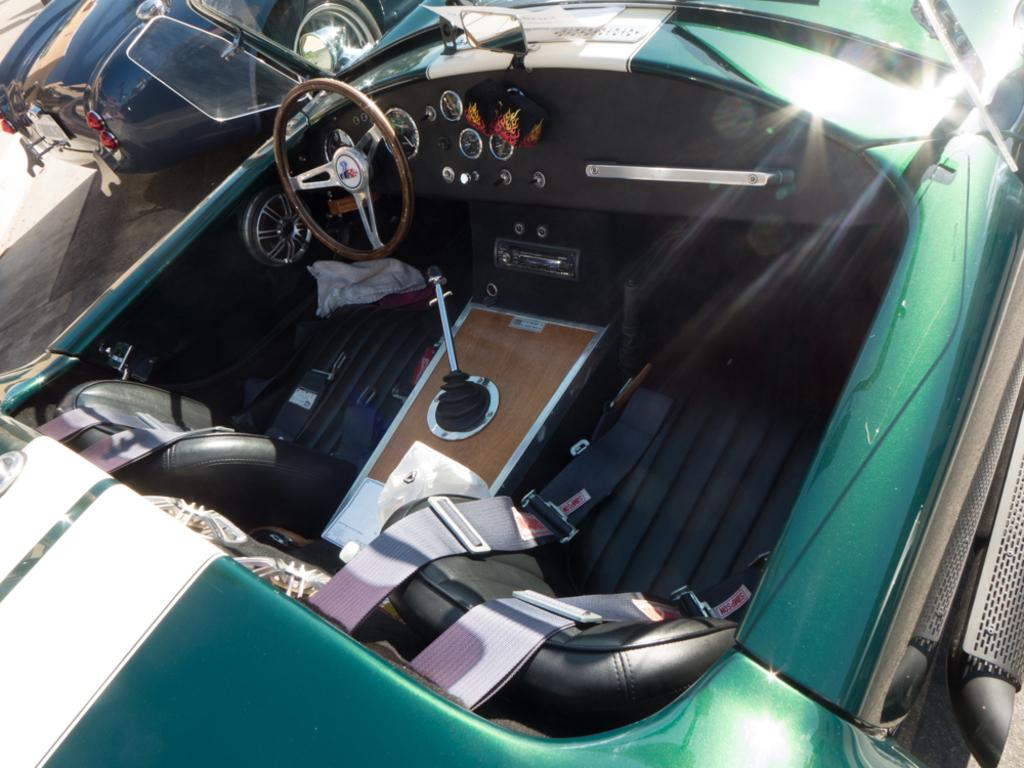What can be seen on the road in the image? There are two vehicles on the road in the image. What features do the vehicles have? The vehicles have steering wheels, speedometers, seats, seat belts, and mirrors. What else can be seen inside the vehicles? There are other objects visible in the vehicles. Where is the scarecrow standing in the image? There is no scarecrow present in the image. How many chickens can be seen in the vehicles? There are no chickens present in the image. 